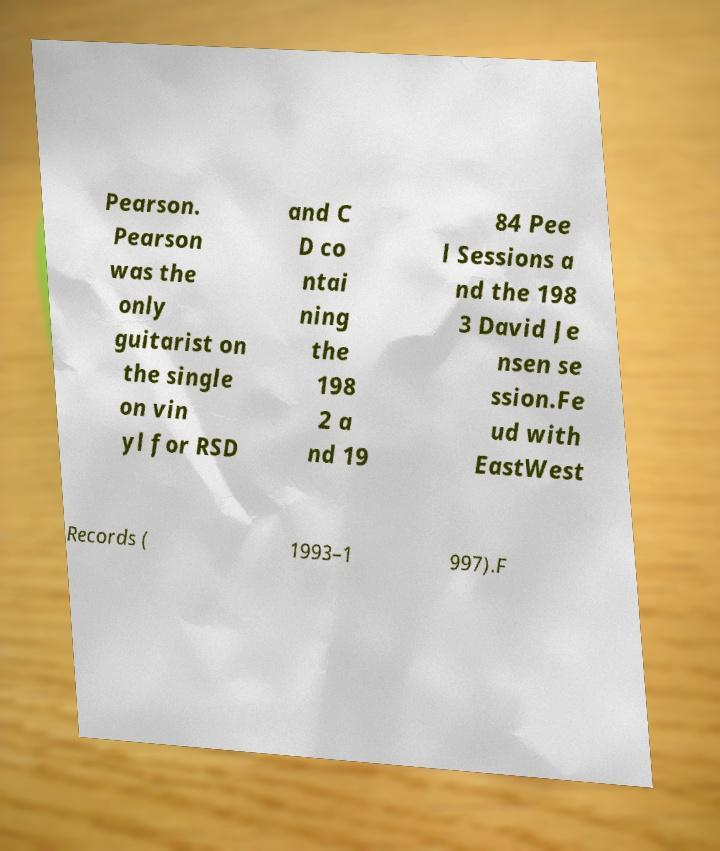Can you accurately transcribe the text from the provided image for me? Pearson. Pearson was the only guitarist on the single on vin yl for RSD and C D co ntai ning the 198 2 a nd 19 84 Pee l Sessions a nd the 198 3 David Je nsen se ssion.Fe ud with EastWest Records ( 1993–1 997).F 